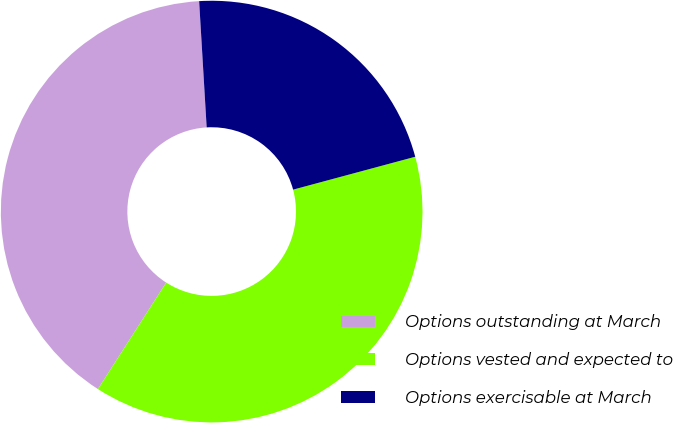Convert chart. <chart><loc_0><loc_0><loc_500><loc_500><pie_chart><fcel>Options outstanding at March<fcel>Options vested and expected to<fcel>Options exercisable at March<nl><fcel>39.98%<fcel>38.26%<fcel>21.76%<nl></chart> 